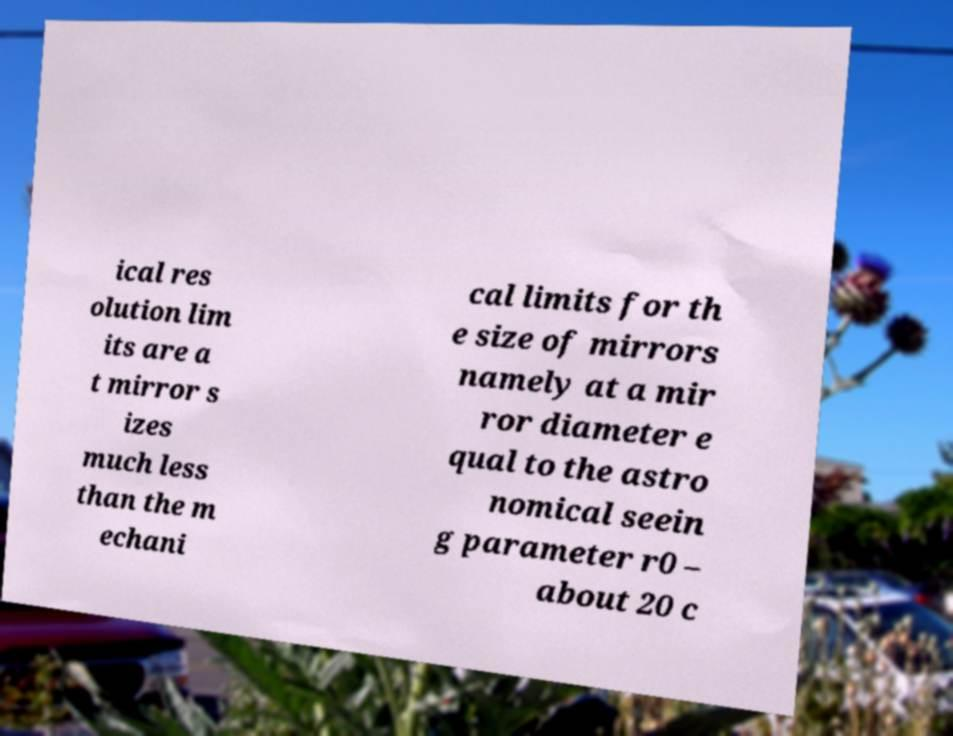Please identify and transcribe the text found in this image. ical res olution lim its are a t mirror s izes much less than the m echani cal limits for th e size of mirrors namely at a mir ror diameter e qual to the astro nomical seein g parameter r0 – about 20 c 